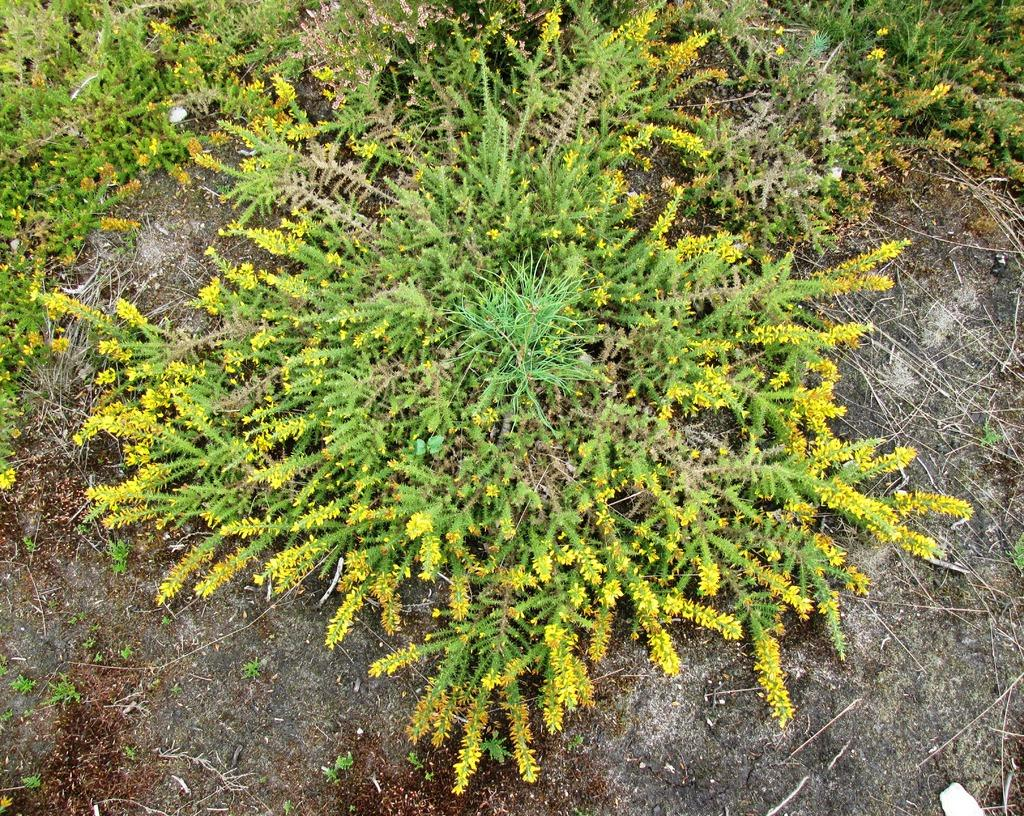What type of vegetation is present in the image? There is grass in the image. What additional feature can be seen in the grass? There are tiny flowers in the image. What color are the tiny flowers? The tiny flowers are yellow in color. How many people are walking on the tiny flowers in the image? There are no people walking on the tiny flowers in the image; the flowers are part of the grass. Can you tell me when the tiny flowers were born in the image? The image does not provide information about the birth of the tiny flowers; it only shows their current state. 